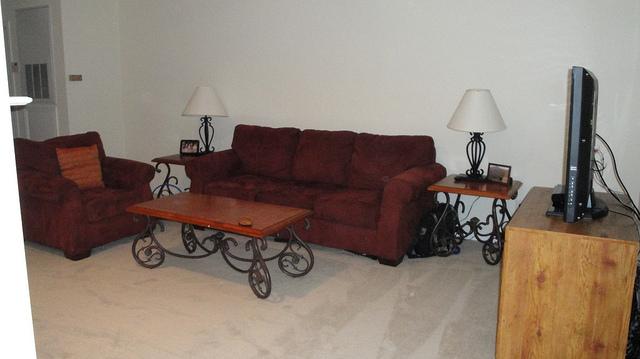What is the coffee table made of?
Keep it brief. Wood. What furniture is between the two lamps?
Short answer required. Couch. How many lamps are pictured?
Keep it brief. 2. 